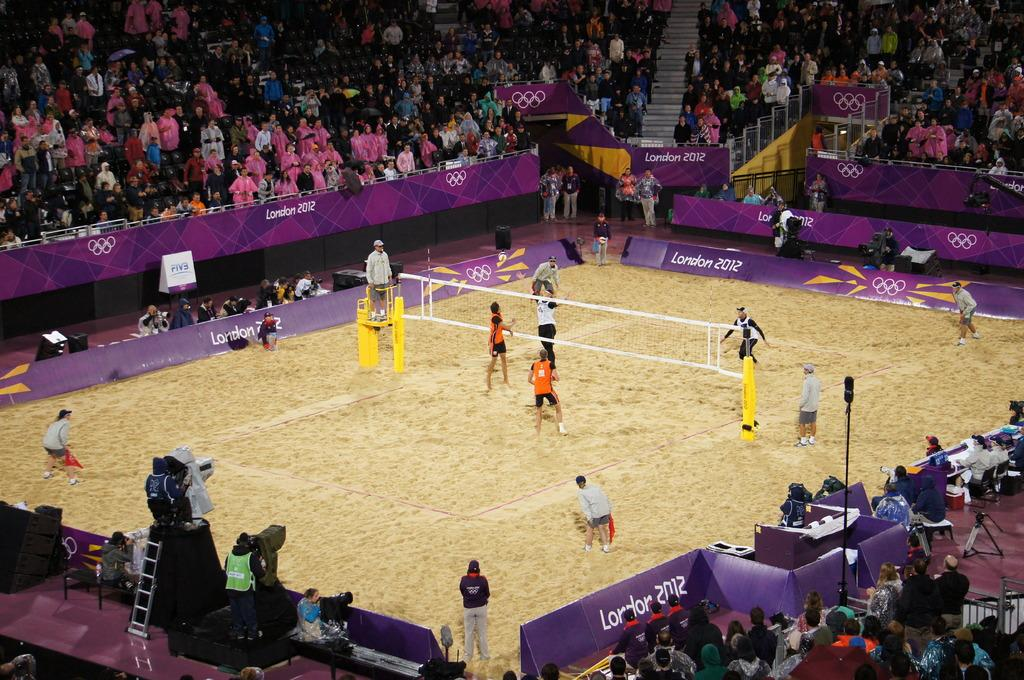What activity are the people in the image engaged in? The people in the image are playing a game. What type of surface is visible in the image? There is sand in the image. What is used to separate the playing area in the game? There is a net in the image. What supports the net in the game? There are poles in the image. What type of advertisements or promotional materials can be seen in the image? There are hoardings in the image. What objects are present in the image? There are objects in the image, but their specific nature is not mentioned in the facts. Who is watching the game in the image? There is an audience in the image. What type of seating is available for the audience? There are chairs in the image. What architectural feature is present in the image? There are steps in the image. What type of flesh can be seen healing on the injured player in the image? There is no mention of an injured player or flesh in the image. How is the game divided into sections in the image? The game is not divided into sections in the image; there is only one net and playing area. Where is the faucet located in the image? There is no faucet present in the image. 